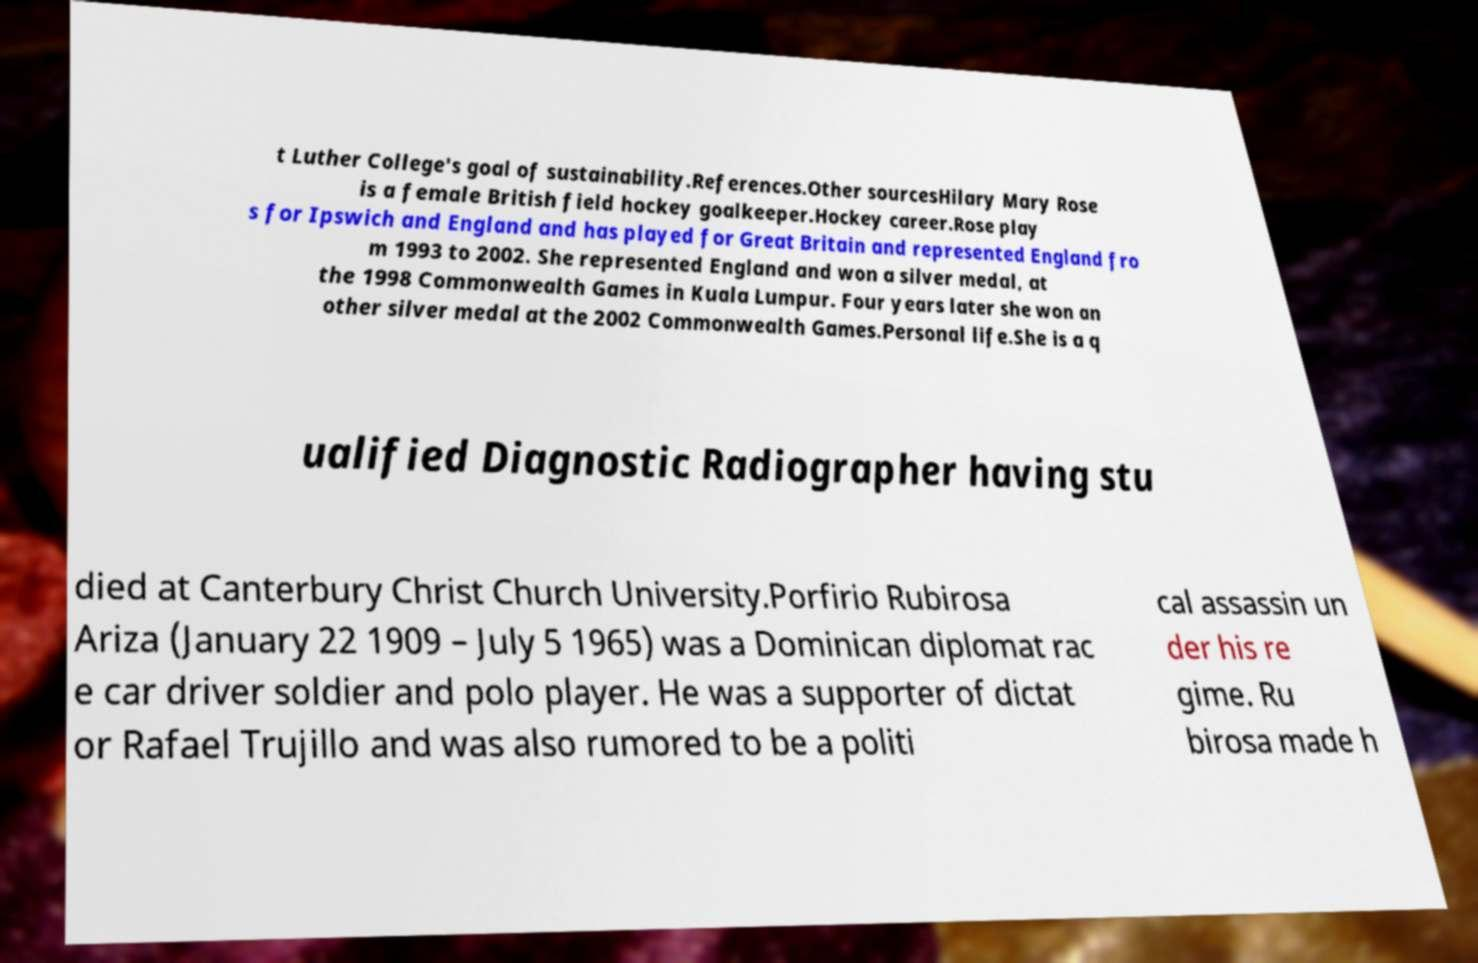Please identify and transcribe the text found in this image. t Luther College's goal of sustainability.References.Other sourcesHilary Mary Rose is a female British field hockey goalkeeper.Hockey career.Rose play s for Ipswich and England and has played for Great Britain and represented England fro m 1993 to 2002. She represented England and won a silver medal, at the 1998 Commonwealth Games in Kuala Lumpur. Four years later she won an other silver medal at the 2002 Commonwealth Games.Personal life.She is a q ualified Diagnostic Radiographer having stu died at Canterbury Christ Church University.Porfirio Rubirosa Ariza (January 22 1909 – July 5 1965) was a Dominican diplomat rac e car driver soldier and polo player. He was a supporter of dictat or Rafael Trujillo and was also rumored to be a politi cal assassin un der his re gime. Ru birosa made h 